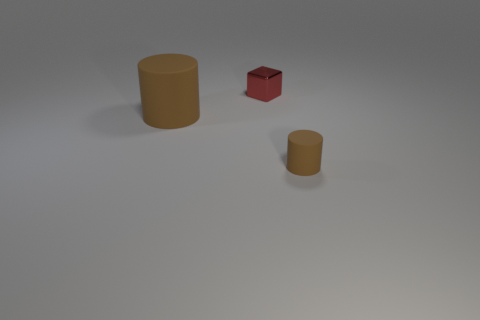How many big objects are red cubes or purple balls?
Make the answer very short. 0. Does the brown object on the left side of the block have the same size as the tiny cube?
Your answer should be very brief. No. How many other objects are there of the same color as the small shiny object?
Make the answer very short. 0. What is the tiny brown thing made of?
Your answer should be very brief. Rubber. What is the object that is both behind the small cylinder and in front of the cube made of?
Offer a terse response. Rubber. How many objects are brown objects in front of the large brown rubber cylinder or small things?
Provide a succinct answer. 2. Is the color of the small cube the same as the tiny matte thing?
Your response must be concise. No. Is there a rubber object of the same size as the red metal thing?
Your answer should be very brief. Yes. How many things are in front of the block and right of the large brown rubber thing?
Provide a succinct answer. 1. There is a red metal thing; how many small things are right of it?
Your answer should be very brief. 1. 